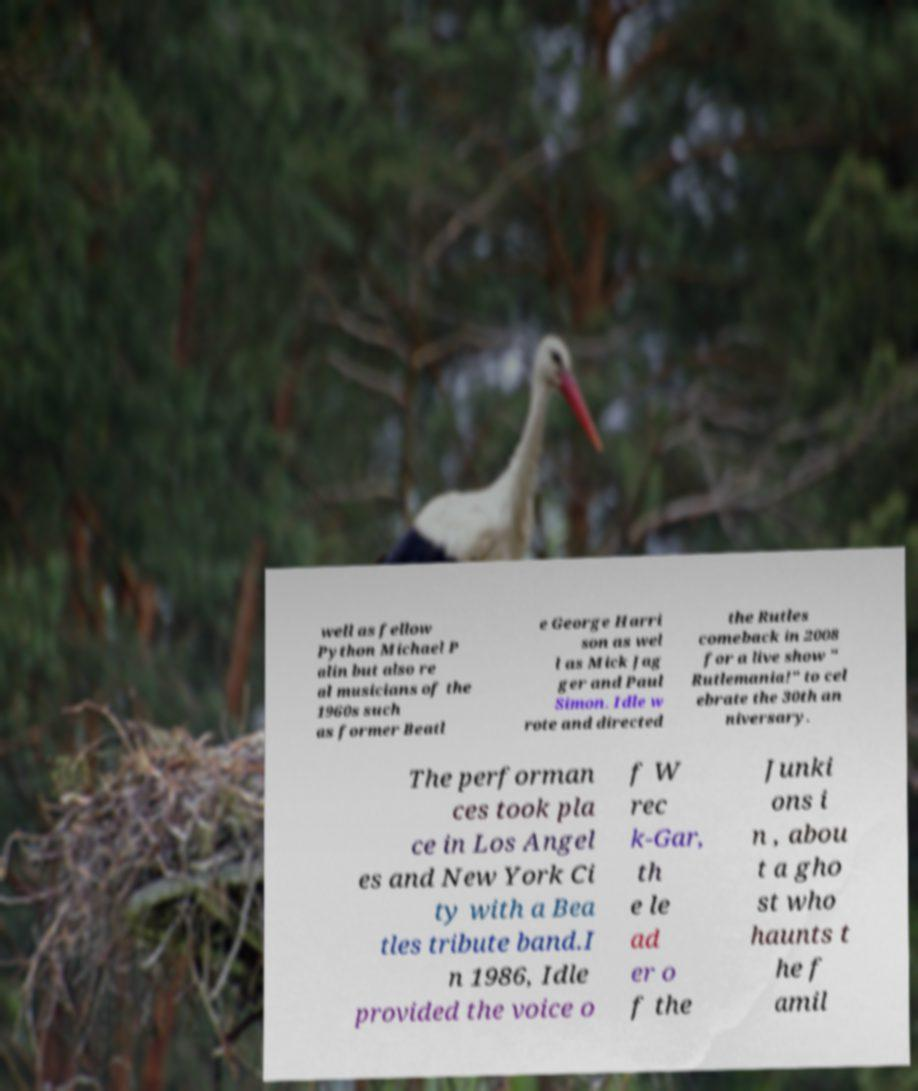There's text embedded in this image that I need extracted. Can you transcribe it verbatim? well as fellow Python Michael P alin but also re al musicians of the 1960s such as former Beatl e George Harri son as wel l as Mick Jag ger and Paul Simon. Idle w rote and directed the Rutles comeback in 2008 for a live show " Rutlemania!" to cel ebrate the 30th an niversary. The performan ces took pla ce in Los Angel es and New York Ci ty with a Bea tles tribute band.I n 1986, Idle provided the voice o f W rec k-Gar, th e le ad er o f the Junki ons i n , abou t a gho st who haunts t he f amil 